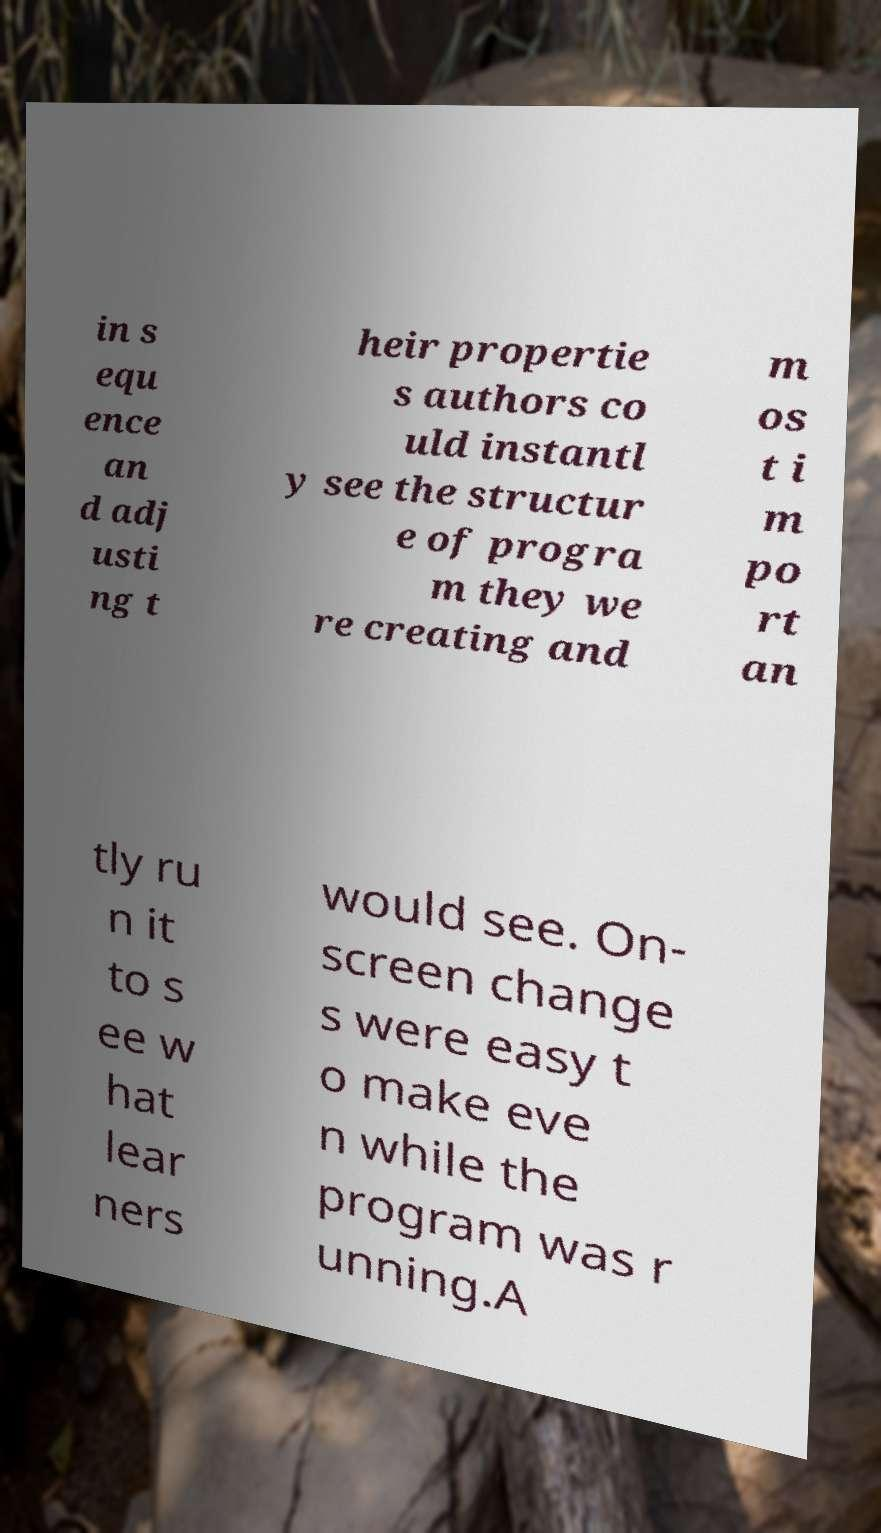Could you assist in decoding the text presented in this image and type it out clearly? in s equ ence an d adj usti ng t heir propertie s authors co uld instantl y see the structur e of progra m they we re creating and m os t i m po rt an tly ru n it to s ee w hat lear ners would see. On- screen change s were easy t o make eve n while the program was r unning.A 